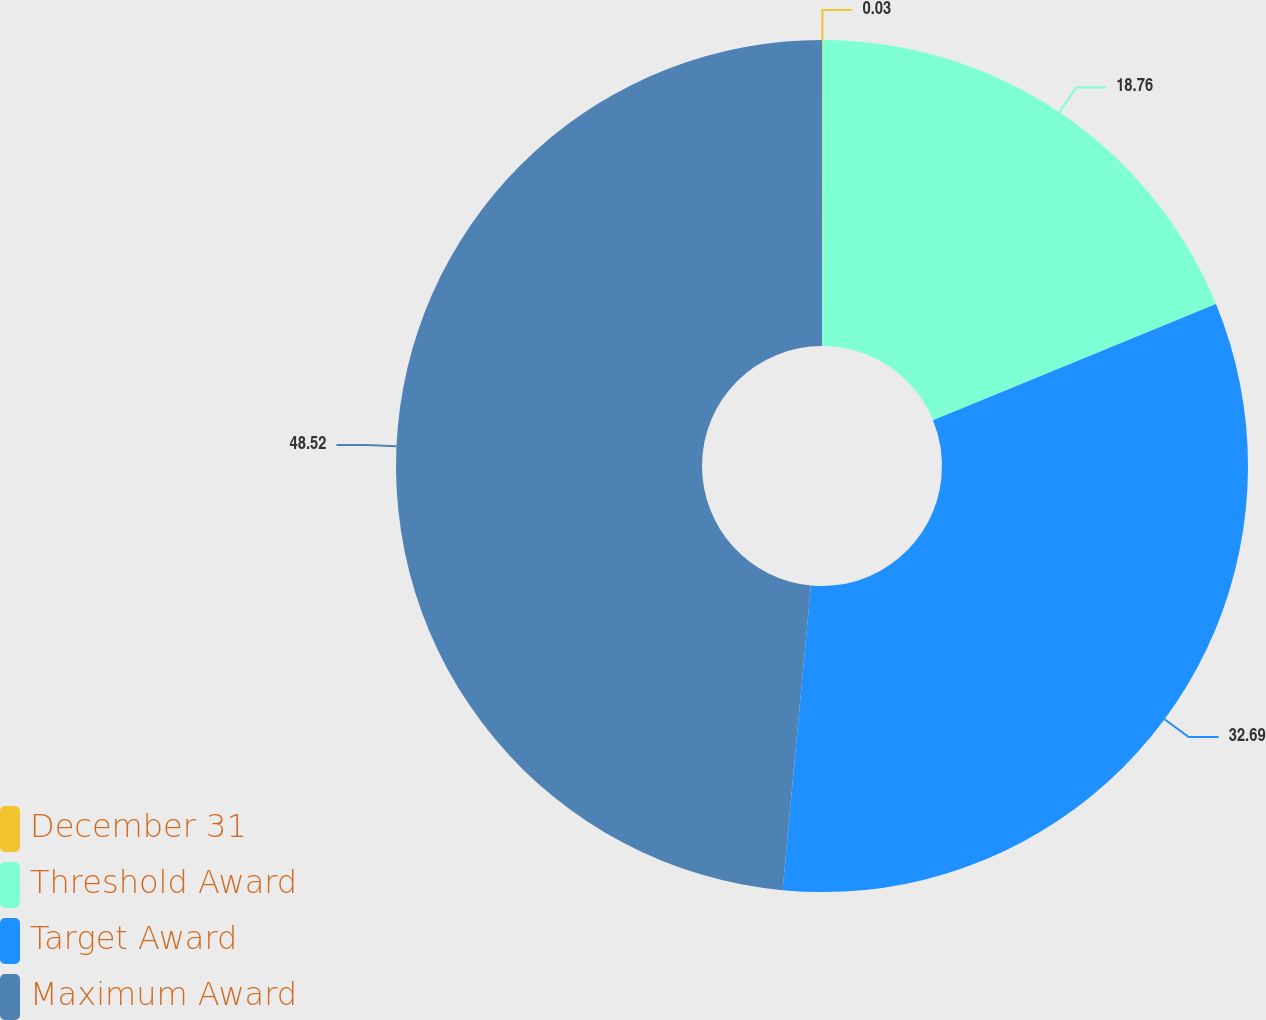Convert chart to OTSL. <chart><loc_0><loc_0><loc_500><loc_500><pie_chart><fcel>December 31<fcel>Threshold Award<fcel>Target Award<fcel>Maximum Award<nl><fcel>0.03%<fcel>18.76%<fcel>32.69%<fcel>48.53%<nl></chart> 